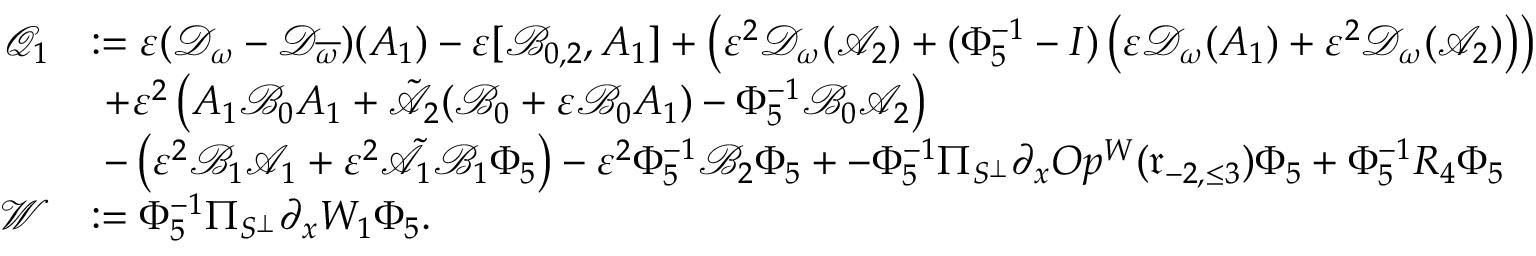Convert formula to latex. <formula><loc_0><loc_0><loc_500><loc_500>\begin{array} { r l } { \mathcal { Q } _ { 1 } } & { \colon = \varepsilon ( \mathcal { D } _ { \omega } - \mathcal { D } _ { \overline { \omega } } ) ( A _ { 1 } ) - \varepsilon [ \mathcal { B } _ { 0 , 2 } , A _ { 1 } ] + \left ( \varepsilon ^ { 2 } \mathcal { D } _ { \omega } ( \mathcal { A } _ { 2 } ) + ( \Phi _ { 5 } ^ { - 1 } - I ) \left ( \varepsilon \mathcal { D } _ { \omega } ( A _ { 1 } ) + \varepsilon ^ { 2 } \mathcal { D } _ { \omega } ( \mathcal { A } _ { 2 } ) \right ) \right ) } \\ & { \ + \varepsilon ^ { 2 } \left ( A _ { 1 } \mathcal { B } _ { 0 } A _ { 1 } + \tilde { \mathcal { A } _ { 2 } } ( \mathcal { B } _ { 0 } + \varepsilon \mathcal { B } _ { 0 } A _ { 1 } ) - \Phi _ { 5 } ^ { - 1 } \mathcal { B } _ { 0 } \mathcal { A } _ { 2 } \right ) } \\ & { \ - \left ( \varepsilon ^ { 2 } \mathcal { B } _ { 1 } \mathcal { A } _ { 1 } + \varepsilon ^ { 2 } \tilde { \mathcal { A } } _ { 1 } \mathcal { B } _ { 1 } \Phi _ { 5 } \right ) - \varepsilon ^ { 2 } \Phi _ { 5 } ^ { - 1 } \mathcal { B } _ { 2 } \Phi _ { 5 } + - \Phi _ { 5 } ^ { - 1 } \Pi _ { S ^ { \perp } } \partial _ { x } O p ^ { W } ( \mathfrak { r } _ { - 2 , \leq 3 } ) \Phi _ { 5 } + \Phi _ { 5 } ^ { - 1 } R _ { 4 } \Phi _ { 5 } } \\ { \mathcal { W } } & { \colon = \Phi _ { 5 } ^ { - 1 } \Pi _ { S ^ { \perp } } \partial _ { x } W _ { 1 } \Phi _ { 5 } . } \end{array}</formula> 